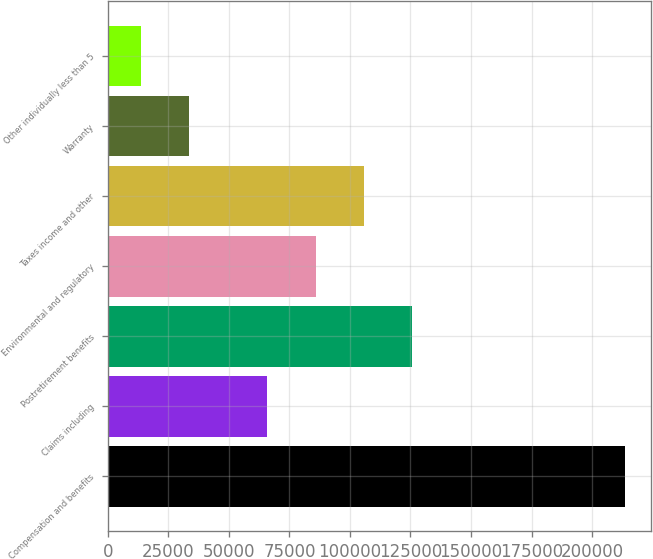Convert chart. <chart><loc_0><loc_0><loc_500><loc_500><bar_chart><fcel>Compensation and benefits<fcel>Claims including<fcel>Postretirement benefits<fcel>Environmental and regulatory<fcel>Taxes income and other<fcel>Warranty<fcel>Other individually less than 5<nl><fcel>213495<fcel>65886<fcel>125819<fcel>85863.8<fcel>105842<fcel>33694.8<fcel>13717<nl></chart> 